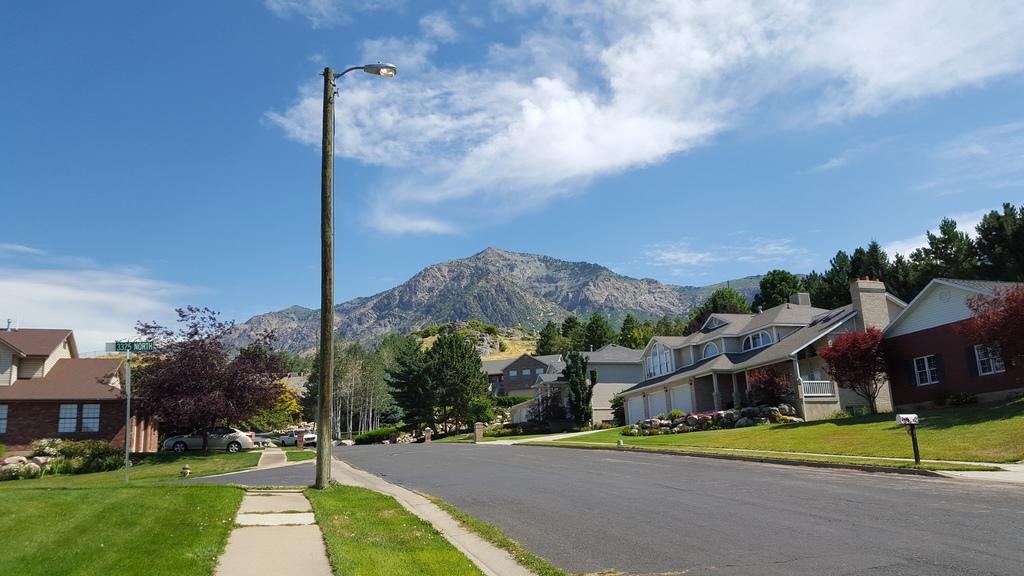What is the main object in the middle of the image? There is a pole in the middle of the image. What can be seen running through the image? There is a road in the image. What type of structures are on the right side of the image? There are houses and trees on the right side of the image. What is visible in the background of the image? There is a hill in the background of the image. What is visible at the top of the image? The sky is visible at the top of the image. How many cakes are displayed on the pole in the image? There are no cakes present on the pole in the image. What type of detail can be seen on the back of the houses in the image? There is no mention of any specific detail on the back of the houses in the image. 